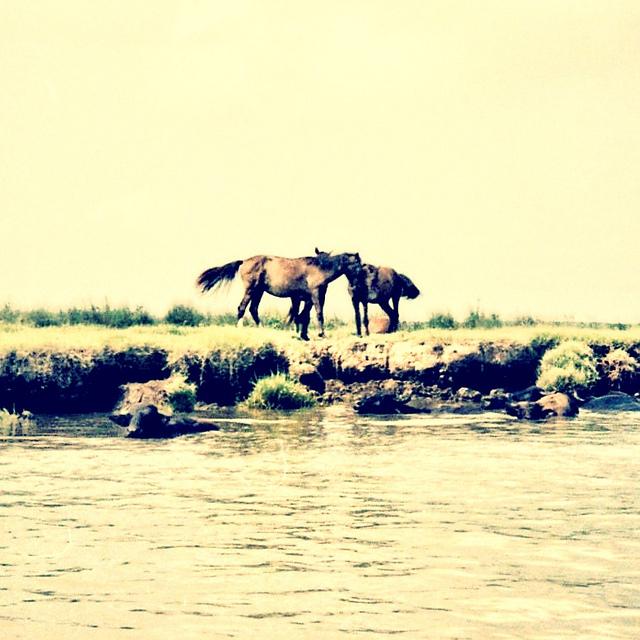Are all of the horses adult horses?
Quick response, please. Yes. Are the animals thirsty?
Be succinct. No. Are there animals in the water?
Short answer required. Yes. How many horses are in the scene?
Short answer required. 2. Are these wild horses?
Keep it brief. Yes. How many horses are standing in the row?
Answer briefly. 2. 